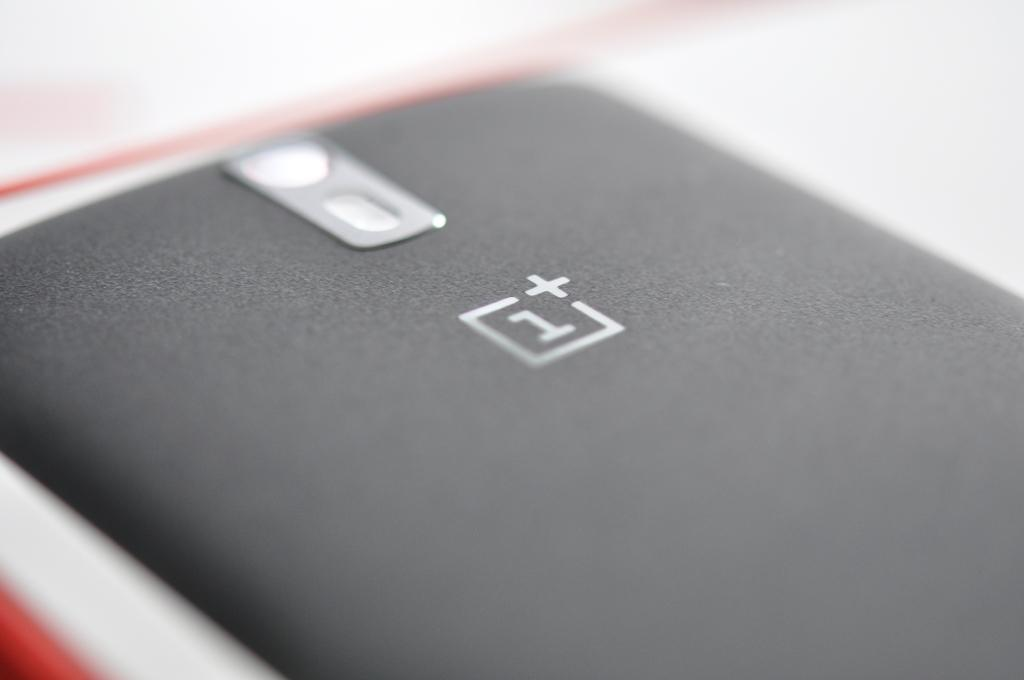<image>
Write a terse but informative summary of the picture. An electronic device turned upside down on its face with a 1 on the back of it. 